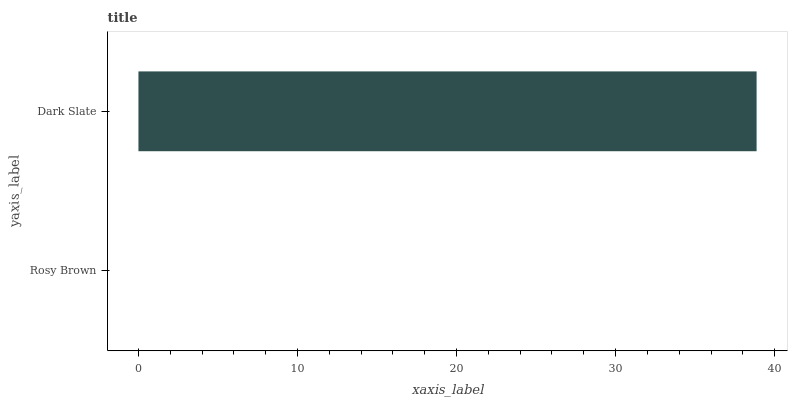Is Rosy Brown the minimum?
Answer yes or no. Yes. Is Dark Slate the maximum?
Answer yes or no. Yes. Is Dark Slate the minimum?
Answer yes or no. No. Is Dark Slate greater than Rosy Brown?
Answer yes or no. Yes. Is Rosy Brown less than Dark Slate?
Answer yes or no. Yes. Is Rosy Brown greater than Dark Slate?
Answer yes or no. No. Is Dark Slate less than Rosy Brown?
Answer yes or no. No. Is Dark Slate the high median?
Answer yes or no. Yes. Is Rosy Brown the low median?
Answer yes or no. Yes. Is Rosy Brown the high median?
Answer yes or no. No. Is Dark Slate the low median?
Answer yes or no. No. 